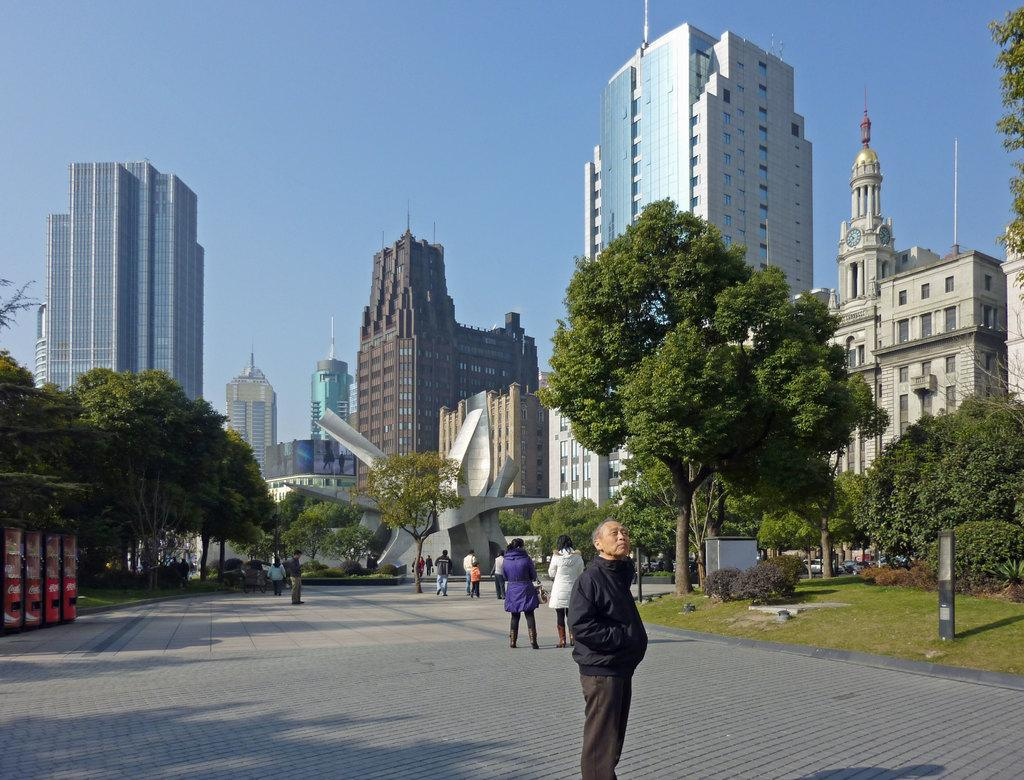What is happening on the road in the image? There are people on the road in the image. What can be seen in the background of the image? There are trees, buildings, poles, and a monument in the background of the image. What type of toy is being used by the people on the road in the image? There is no toy present in the image; it features people on the road and various background elements. What kind of apparel are the people wearing in the image? The provided facts do not mention the apparel of the people in the image. 